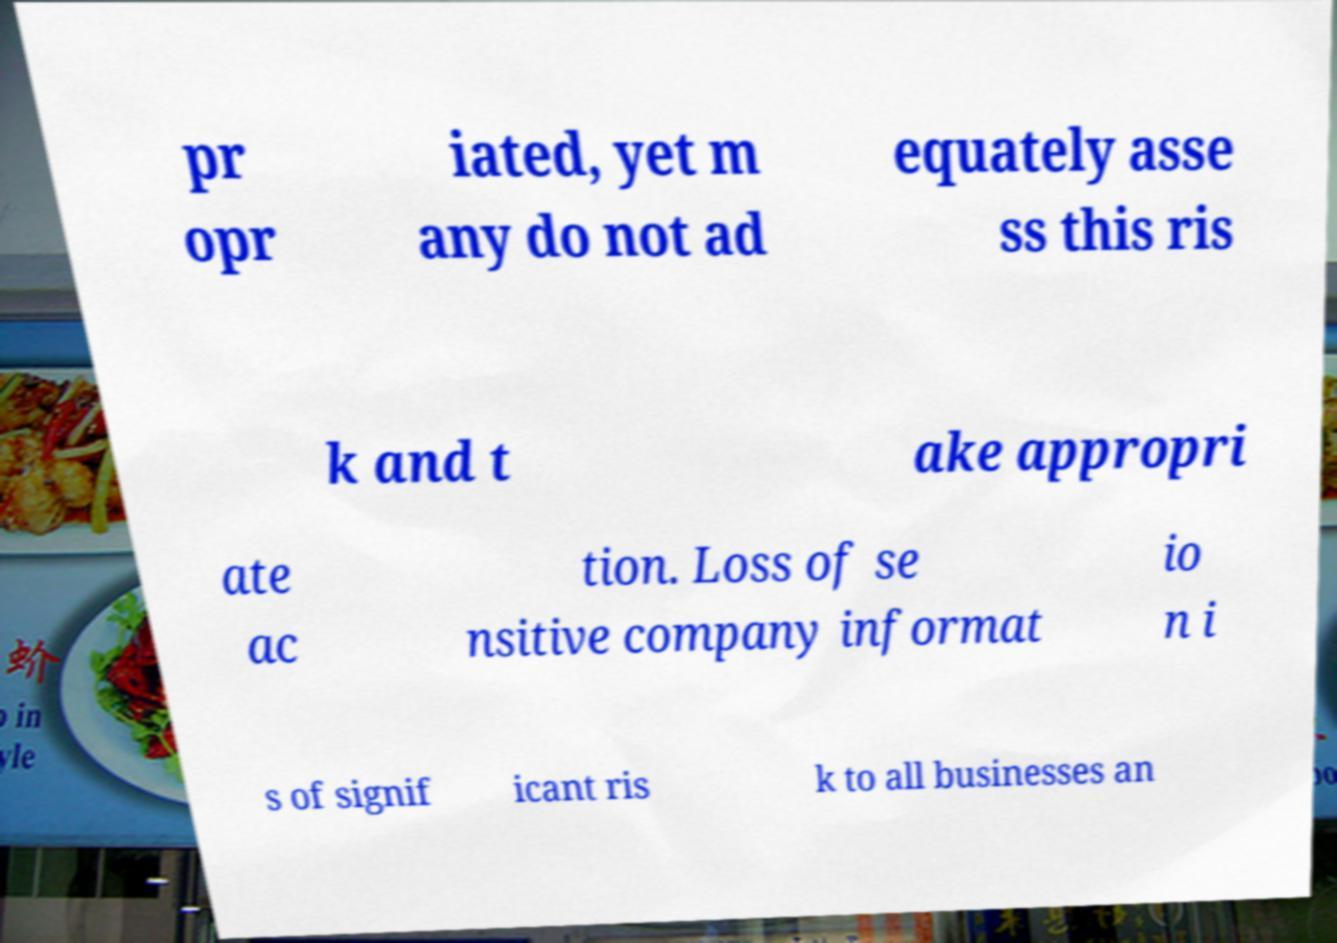Please read and relay the text visible in this image. What does it say? pr opr iated, yet m any do not ad equately asse ss this ris k and t ake appropri ate ac tion. Loss of se nsitive company informat io n i s of signif icant ris k to all businesses an 